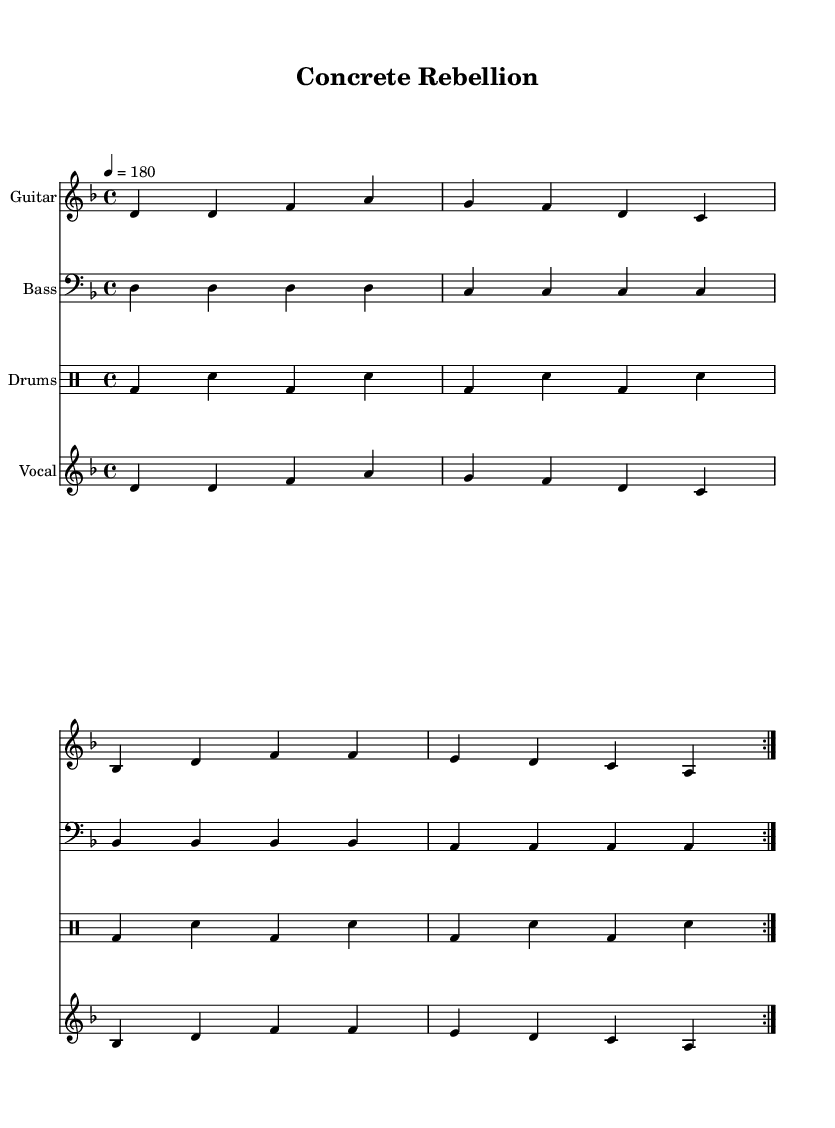What is the key signature of this music? The key signature is represented by the placement of sharps or flats at the beginning of the staff. In this case, there are no sharps or flats indicated, so it confirms that the key signature is D minor.
Answer: D minor What is the time signature of this music? The time signature is indicated after the key signature at the beginning of the staff. Here, it shows four beats per measure which is noted as 4/4.
Answer: 4/4 What is the tempo marking for this piece? The tempo marking is indicated in the score, where it states "4 = 180." This signifies that there are 180 beats per minute.
Answer: 180 How many times is the main theme repeated in the song? The score features a "repeat volta" notation which indicates that the two main sections (the measures listed under guitar and vocals) are to be played two times.
Answer: 2 What is the vocal range indicated in this music? The vocal part is notated using a treble clef and starts from D above middle C going up to A. Thus it encompasses a range of a minor sixth, which is characteristic for punk vocals.
Answer: D to A What do the lyrics in the chorus address? The lyrics in the chorus focus on rejecting the construction of stadiums in the neighborhood, emphasizing community strength and the idea of not conceding defeat. This reflects the DIY punk ethos of neighborhood solidarity.
Answer: Neighborhood solidarity Which instruments are included in this score? The score consists of a guitar, bass guitar, drums, and vocal parts, each labeled accordingly to reflect the instrumentation used in a typical punk band setup.
Answer: Guitar, bass, drums, vocals 